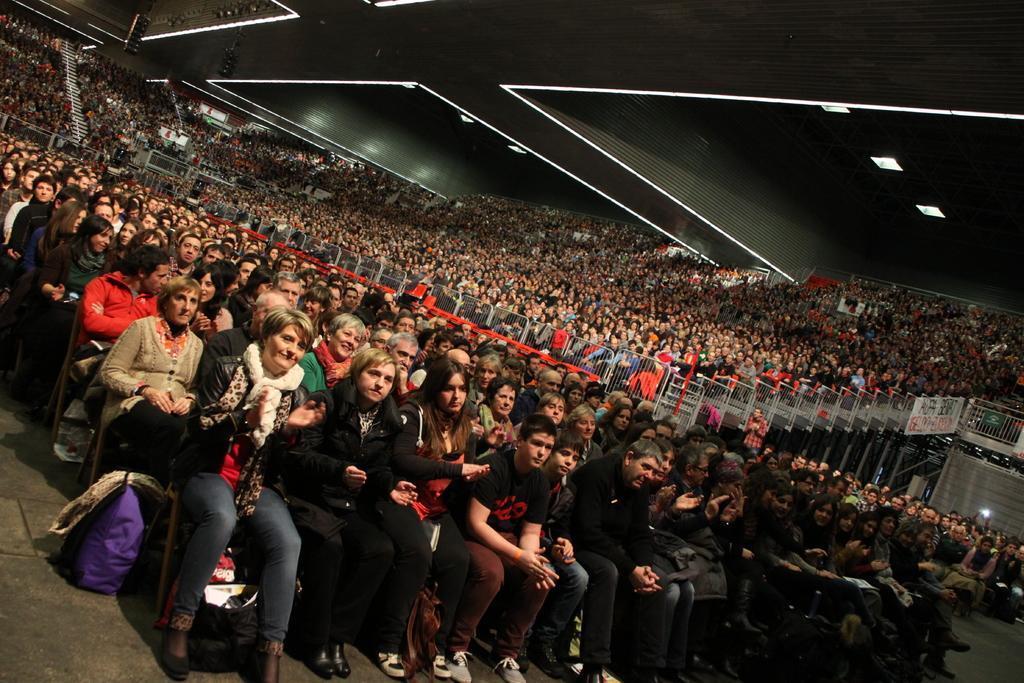Can you describe this image briefly? This image consists of many people sitting on the chairs. It looks like a stadium. At the top, there is a roof along with lights. At the bottom, there is a floor. 